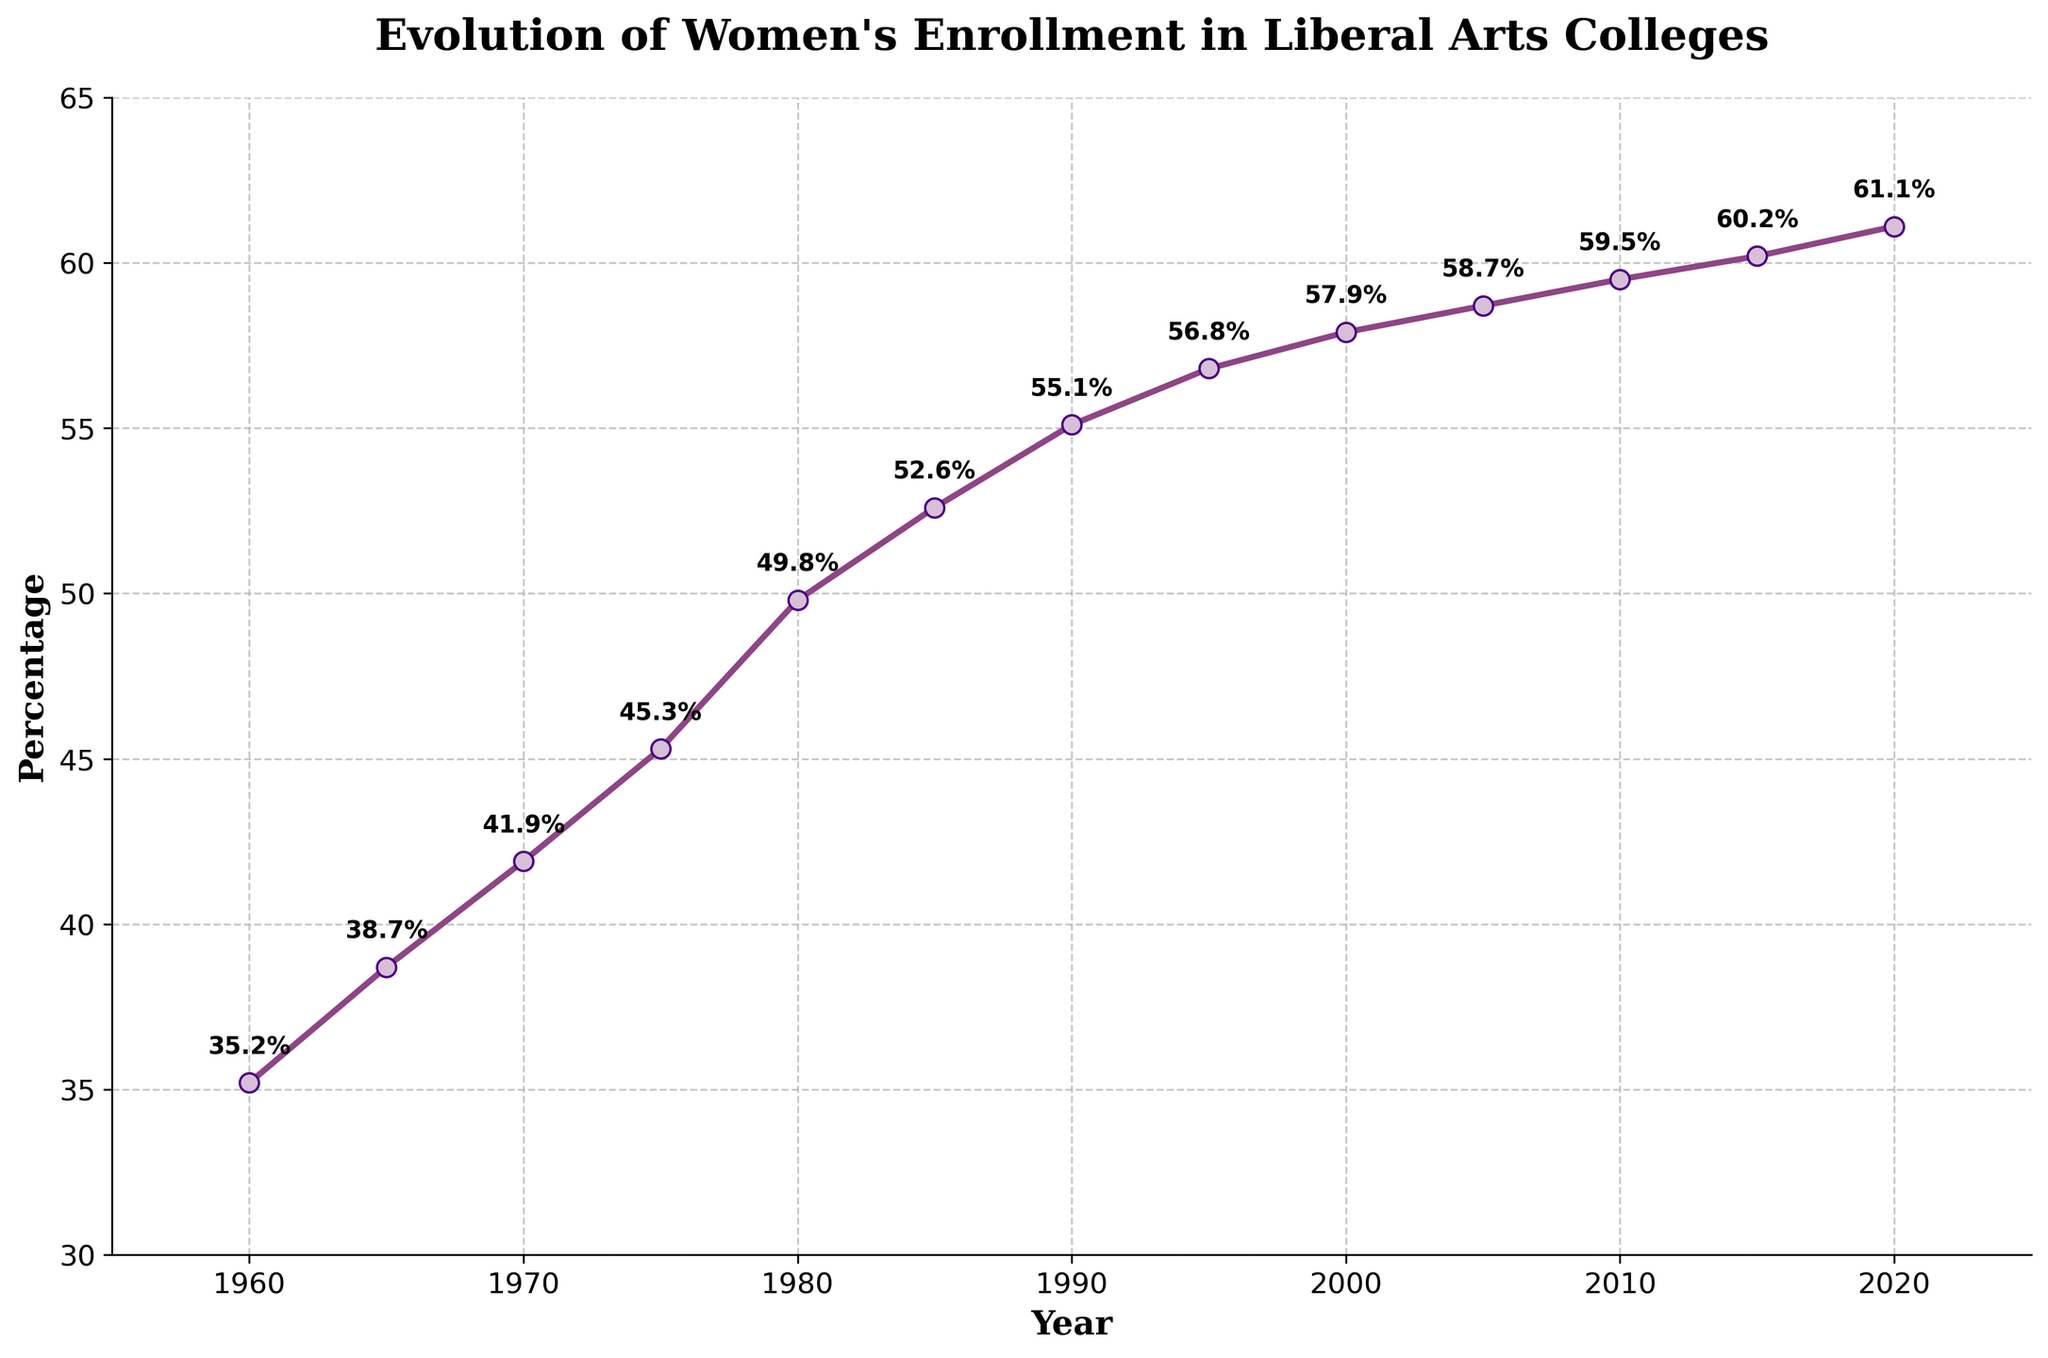What is the percentage change in women's enrollment from 1960 to 2020? The percentage in 1960 was 35.2%, and in 2020 it was 61.1%. To find the change, subtract the 1960 value from the 2020 value: 61.1 - 35.2 = 25.9%.
Answer: 25.9% Which year marks the first time women's enrollment surpassed 50%? From the figure, we see that the percentage surpasses 50% in the year 1980, where it reaches 52.6%.
Answer: 1980 What is the average percentage of women's enrollment between 1960 and 2020? Adding the values for each year from 1960 to 2020 and dividing by 13 results in: (35.2 + 38.7 + 41.9 + 45.3 + 49.8 + 52.6 + 55.1 + 56.8 + 57.9 + 58.7 + 59.5 + 60.2 + 61.1) / 13, which equals approximately 51.9%.
Answer: 51.9% Between 1960 and 2020, during which decade did women's enrollment see the greatest numerical increase? We need to find the difference in percentage for each decade: 
1960-1970: 41.9 - 35.2 = 6.7%
1970-1980: 49.8 - 41.9 = 7.9%
1980-1990: 55.1 - 52.6 = 2.5%
1990-2000: 57.9 - 55.1 = 2.8%
2000-2010: 59.5 - 57.9 = 1.6%
2010-2020: 61.1 - 59.5 = 1.6%
The greatest numerical increase is from 1970 to 1980, at 7.9%.
Answer: 1970-1980 In which years did the percentage of women's enrollment increase the least? We need to examine each interval: 
1960-1965: 38.7 - 35.2 = 3.5%
1965-1970: 41.9 - 38.7 = 3.2%
1970-1975: 45.3 - 41.9 = 3.4%
1975-1980: 49.8 - 45.3 = 4.5%
1980-1985: 52.6 - 49.8 = 2.8%
1985-1990: 55.1 - 52.6 = 2.5%
1990-1995: 56.8 - 55.1 = 1.7%
1995-2000: 57.9 - 56.8 = 1.1%
2000-2005: 58.7 - 57.9 = 0.8%
2005-2010: 59.5 - 58.7 = 0.8%
2010-2015: 60.2 - 59.5 = 0.7%
2015-2020: 61.1 - 60.2 = 0.9%
The least increase happened between 2010 to 2015, with an increase of only 0.7%.
Answer: 2010-2015 Which visual elements highlight the trend in women's enrollment over time? The line plot shows the trend using a continuous line with marker points for each year. The increasing slope and annotated percentages emphasize the upward trend clearly.
Answer: Line plot with markers and annotations From the graph, how does women's enrollment in 2020 compare to that in 1980? In 1980, the percentage was 49.8%, and in 2020 it was 61.1%. The percentage in 2020 is higher by 11.3%.
Answer: 11.3% higher Is there a year where the increase in women's enrollment was particularly significant? The year 1980 shows a notable increase, as it marks the first time the enrollment percentage surpasses 50%, climbing to 52.6%.
Answer: 1980 What can be inferred about women's enrollment trends from 2000 to 2020? From 2000 (57.9%) to 2020 (61.1%), the increase is slower compared to earlier periods, showing a more gradual rise of only 3.2% over 20 years.
Answer: Gradual increase 